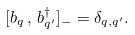Convert formula to latex. <formula><loc_0><loc_0><loc_500><loc_500>[ b _ { q } \, , \, b ^ { \dagger } _ { q ^ { \prime } } ] _ { - } = \delta _ { q , q ^ { \prime } } .</formula> 